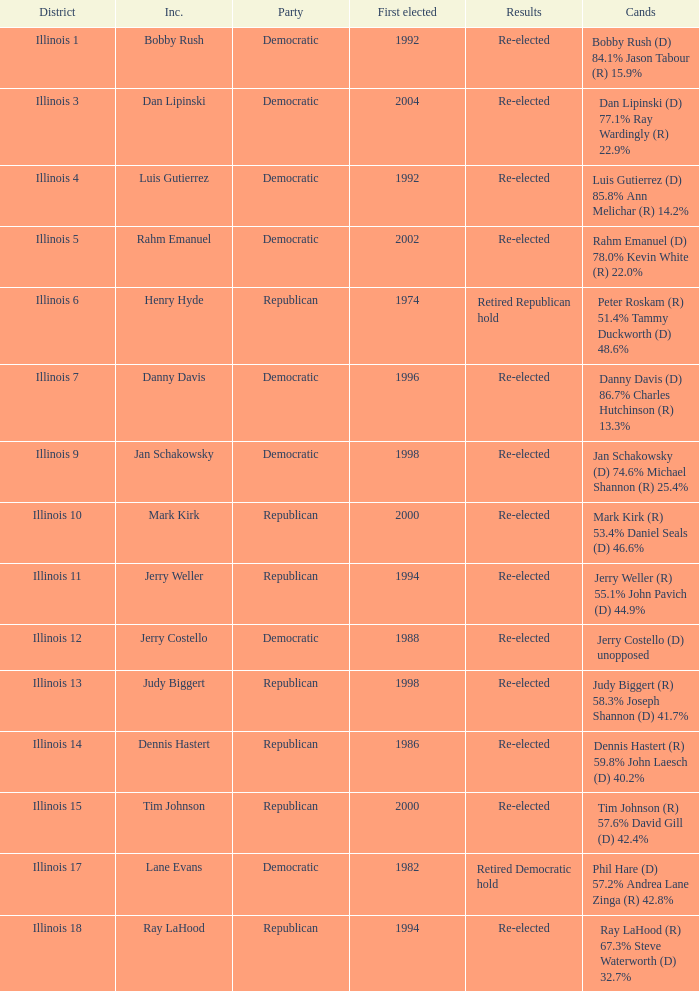Who were the candidates when the first elected was a republican in 1998?  Judy Biggert (R) 58.3% Joseph Shannon (D) 41.7%. Would you mind parsing the complete table? {'header': ['District', 'Inc.', 'Party', 'First elected', 'Results', 'Cands'], 'rows': [['Illinois 1', 'Bobby Rush', 'Democratic', '1992', 'Re-elected', 'Bobby Rush (D) 84.1% Jason Tabour (R) 15.9%'], ['Illinois 3', 'Dan Lipinski', 'Democratic', '2004', 'Re-elected', 'Dan Lipinski (D) 77.1% Ray Wardingly (R) 22.9%'], ['Illinois 4', 'Luis Gutierrez', 'Democratic', '1992', 'Re-elected', 'Luis Gutierrez (D) 85.8% Ann Melichar (R) 14.2%'], ['Illinois 5', 'Rahm Emanuel', 'Democratic', '2002', 'Re-elected', 'Rahm Emanuel (D) 78.0% Kevin White (R) 22.0%'], ['Illinois 6', 'Henry Hyde', 'Republican', '1974', 'Retired Republican hold', 'Peter Roskam (R) 51.4% Tammy Duckworth (D) 48.6%'], ['Illinois 7', 'Danny Davis', 'Democratic', '1996', 'Re-elected', 'Danny Davis (D) 86.7% Charles Hutchinson (R) 13.3%'], ['Illinois 9', 'Jan Schakowsky', 'Democratic', '1998', 'Re-elected', 'Jan Schakowsky (D) 74.6% Michael Shannon (R) 25.4%'], ['Illinois 10', 'Mark Kirk', 'Republican', '2000', 'Re-elected', 'Mark Kirk (R) 53.4% Daniel Seals (D) 46.6%'], ['Illinois 11', 'Jerry Weller', 'Republican', '1994', 'Re-elected', 'Jerry Weller (R) 55.1% John Pavich (D) 44.9%'], ['Illinois 12', 'Jerry Costello', 'Democratic', '1988', 'Re-elected', 'Jerry Costello (D) unopposed'], ['Illinois 13', 'Judy Biggert', 'Republican', '1998', 'Re-elected', 'Judy Biggert (R) 58.3% Joseph Shannon (D) 41.7%'], ['Illinois 14', 'Dennis Hastert', 'Republican', '1986', 'Re-elected', 'Dennis Hastert (R) 59.8% John Laesch (D) 40.2%'], ['Illinois 15', 'Tim Johnson', 'Republican', '2000', 'Re-elected', 'Tim Johnson (R) 57.6% David Gill (D) 42.4%'], ['Illinois 17', 'Lane Evans', 'Democratic', '1982', 'Retired Democratic hold', 'Phil Hare (D) 57.2% Andrea Lane Zinga (R) 42.8%'], ['Illinois 18', 'Ray LaHood', 'Republican', '1994', 'Re-elected', 'Ray LaHood (R) 67.3% Steve Waterworth (D) 32.7%']]} 